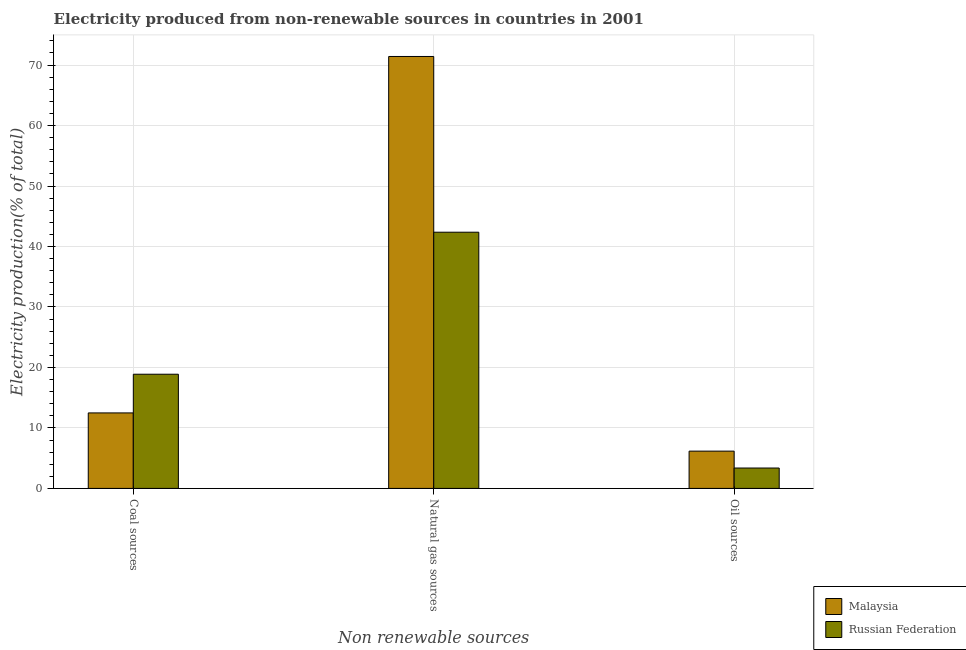How many different coloured bars are there?
Give a very brief answer. 2. Are the number of bars on each tick of the X-axis equal?
Offer a very short reply. Yes. What is the label of the 2nd group of bars from the left?
Make the answer very short. Natural gas sources. What is the percentage of electricity produced by coal in Malaysia?
Make the answer very short. 12.49. Across all countries, what is the maximum percentage of electricity produced by coal?
Provide a short and direct response. 18.88. Across all countries, what is the minimum percentage of electricity produced by oil sources?
Provide a short and direct response. 3.37. In which country was the percentage of electricity produced by oil sources maximum?
Provide a short and direct response. Malaysia. In which country was the percentage of electricity produced by natural gas minimum?
Your response must be concise. Russian Federation. What is the total percentage of electricity produced by natural gas in the graph?
Your answer should be very brief. 113.78. What is the difference between the percentage of electricity produced by coal in Russian Federation and that in Malaysia?
Give a very brief answer. 6.4. What is the difference between the percentage of electricity produced by coal in Russian Federation and the percentage of electricity produced by oil sources in Malaysia?
Make the answer very short. 12.72. What is the average percentage of electricity produced by natural gas per country?
Your answer should be compact. 56.89. What is the difference between the percentage of electricity produced by natural gas and percentage of electricity produced by oil sources in Russian Federation?
Provide a short and direct response. 38.99. In how many countries, is the percentage of electricity produced by natural gas greater than 28 %?
Offer a very short reply. 2. What is the ratio of the percentage of electricity produced by coal in Malaysia to that in Russian Federation?
Your answer should be very brief. 0.66. What is the difference between the highest and the second highest percentage of electricity produced by oil sources?
Your answer should be very brief. 2.79. What is the difference between the highest and the lowest percentage of electricity produced by coal?
Your answer should be compact. 6.4. In how many countries, is the percentage of electricity produced by natural gas greater than the average percentage of electricity produced by natural gas taken over all countries?
Keep it short and to the point. 1. What does the 1st bar from the left in Oil sources represents?
Give a very brief answer. Malaysia. What does the 2nd bar from the right in Natural gas sources represents?
Make the answer very short. Malaysia. Is it the case that in every country, the sum of the percentage of electricity produced by coal and percentage of electricity produced by natural gas is greater than the percentage of electricity produced by oil sources?
Make the answer very short. Yes. Are all the bars in the graph horizontal?
Make the answer very short. No. Are the values on the major ticks of Y-axis written in scientific E-notation?
Offer a very short reply. No. Does the graph contain any zero values?
Your answer should be compact. No. Does the graph contain grids?
Provide a succinct answer. Yes. Where does the legend appear in the graph?
Keep it short and to the point. Bottom right. What is the title of the graph?
Your response must be concise. Electricity produced from non-renewable sources in countries in 2001. What is the label or title of the X-axis?
Provide a short and direct response. Non renewable sources. What is the Electricity production(% of total) in Malaysia in Coal sources?
Your response must be concise. 12.49. What is the Electricity production(% of total) of Russian Federation in Coal sources?
Your answer should be very brief. 18.88. What is the Electricity production(% of total) of Malaysia in Natural gas sources?
Ensure brevity in your answer.  71.42. What is the Electricity production(% of total) in Russian Federation in Natural gas sources?
Provide a short and direct response. 42.36. What is the Electricity production(% of total) of Malaysia in Oil sources?
Keep it short and to the point. 6.16. What is the Electricity production(% of total) of Russian Federation in Oil sources?
Offer a terse response. 3.37. Across all Non renewable sources, what is the maximum Electricity production(% of total) in Malaysia?
Your answer should be compact. 71.42. Across all Non renewable sources, what is the maximum Electricity production(% of total) of Russian Federation?
Keep it short and to the point. 42.36. Across all Non renewable sources, what is the minimum Electricity production(% of total) in Malaysia?
Keep it short and to the point. 6.16. Across all Non renewable sources, what is the minimum Electricity production(% of total) of Russian Federation?
Offer a terse response. 3.37. What is the total Electricity production(% of total) of Malaysia in the graph?
Keep it short and to the point. 90.07. What is the total Electricity production(% of total) of Russian Federation in the graph?
Make the answer very short. 64.62. What is the difference between the Electricity production(% of total) in Malaysia in Coal sources and that in Natural gas sources?
Offer a terse response. -58.94. What is the difference between the Electricity production(% of total) of Russian Federation in Coal sources and that in Natural gas sources?
Keep it short and to the point. -23.48. What is the difference between the Electricity production(% of total) of Malaysia in Coal sources and that in Oil sources?
Provide a succinct answer. 6.32. What is the difference between the Electricity production(% of total) in Russian Federation in Coal sources and that in Oil sources?
Provide a short and direct response. 15.51. What is the difference between the Electricity production(% of total) in Malaysia in Natural gas sources and that in Oil sources?
Ensure brevity in your answer.  65.26. What is the difference between the Electricity production(% of total) in Russian Federation in Natural gas sources and that in Oil sources?
Offer a very short reply. 38.99. What is the difference between the Electricity production(% of total) of Malaysia in Coal sources and the Electricity production(% of total) of Russian Federation in Natural gas sources?
Offer a terse response. -29.88. What is the difference between the Electricity production(% of total) of Malaysia in Coal sources and the Electricity production(% of total) of Russian Federation in Oil sources?
Offer a very short reply. 9.11. What is the difference between the Electricity production(% of total) of Malaysia in Natural gas sources and the Electricity production(% of total) of Russian Federation in Oil sources?
Make the answer very short. 68.05. What is the average Electricity production(% of total) in Malaysia per Non renewable sources?
Give a very brief answer. 30.02. What is the average Electricity production(% of total) in Russian Federation per Non renewable sources?
Provide a succinct answer. 21.54. What is the difference between the Electricity production(% of total) of Malaysia and Electricity production(% of total) of Russian Federation in Coal sources?
Keep it short and to the point. -6.4. What is the difference between the Electricity production(% of total) in Malaysia and Electricity production(% of total) in Russian Federation in Natural gas sources?
Keep it short and to the point. 29.06. What is the difference between the Electricity production(% of total) in Malaysia and Electricity production(% of total) in Russian Federation in Oil sources?
Provide a succinct answer. 2.79. What is the ratio of the Electricity production(% of total) in Malaysia in Coal sources to that in Natural gas sources?
Provide a succinct answer. 0.17. What is the ratio of the Electricity production(% of total) of Russian Federation in Coal sources to that in Natural gas sources?
Provide a short and direct response. 0.45. What is the ratio of the Electricity production(% of total) in Malaysia in Coal sources to that in Oil sources?
Offer a terse response. 2.03. What is the ratio of the Electricity production(% of total) of Russian Federation in Coal sources to that in Oil sources?
Provide a succinct answer. 5.6. What is the ratio of the Electricity production(% of total) in Malaysia in Natural gas sources to that in Oil sources?
Give a very brief answer. 11.59. What is the ratio of the Electricity production(% of total) in Russian Federation in Natural gas sources to that in Oil sources?
Give a very brief answer. 12.56. What is the difference between the highest and the second highest Electricity production(% of total) of Malaysia?
Provide a short and direct response. 58.94. What is the difference between the highest and the second highest Electricity production(% of total) of Russian Federation?
Offer a very short reply. 23.48. What is the difference between the highest and the lowest Electricity production(% of total) of Malaysia?
Offer a terse response. 65.26. What is the difference between the highest and the lowest Electricity production(% of total) of Russian Federation?
Offer a terse response. 38.99. 